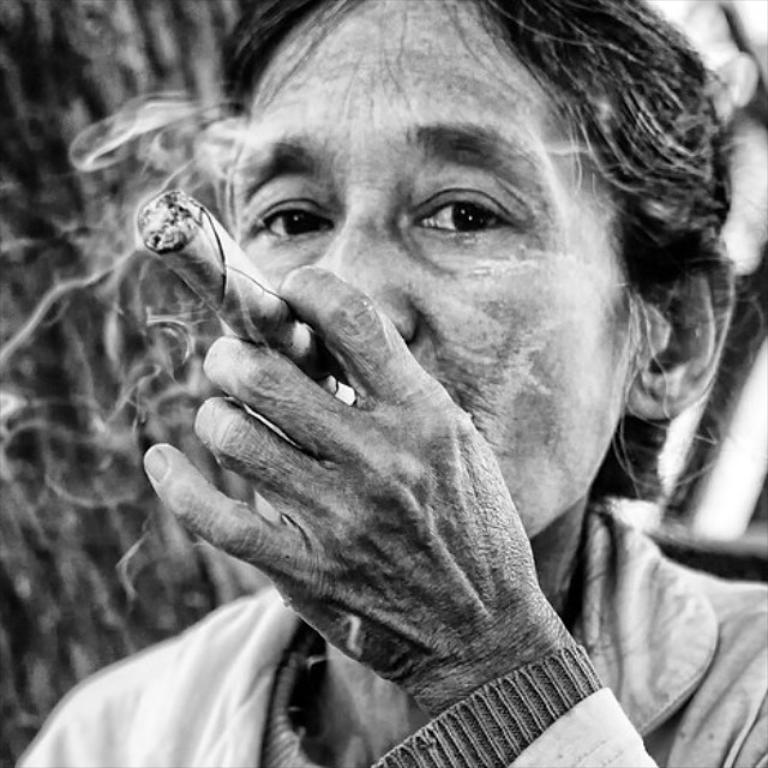What type of picture is in the image? There is a black and white picture of a woman in the image. What is the woman wearing in the picture? The woman is wearing a dress in the picture. What is the woman holding in her hand? The woman is holding a cigar in her hand. What else can be seen in the background of the picture? There are other objects visible in the background of the image. How many sugar cubes are on the table next to the woman in the image? There is no table or sugar cubes visible in the image. What type of slave is depicted in the image? There is no depiction of a slave in the image; it features a woman holding a cigar. 